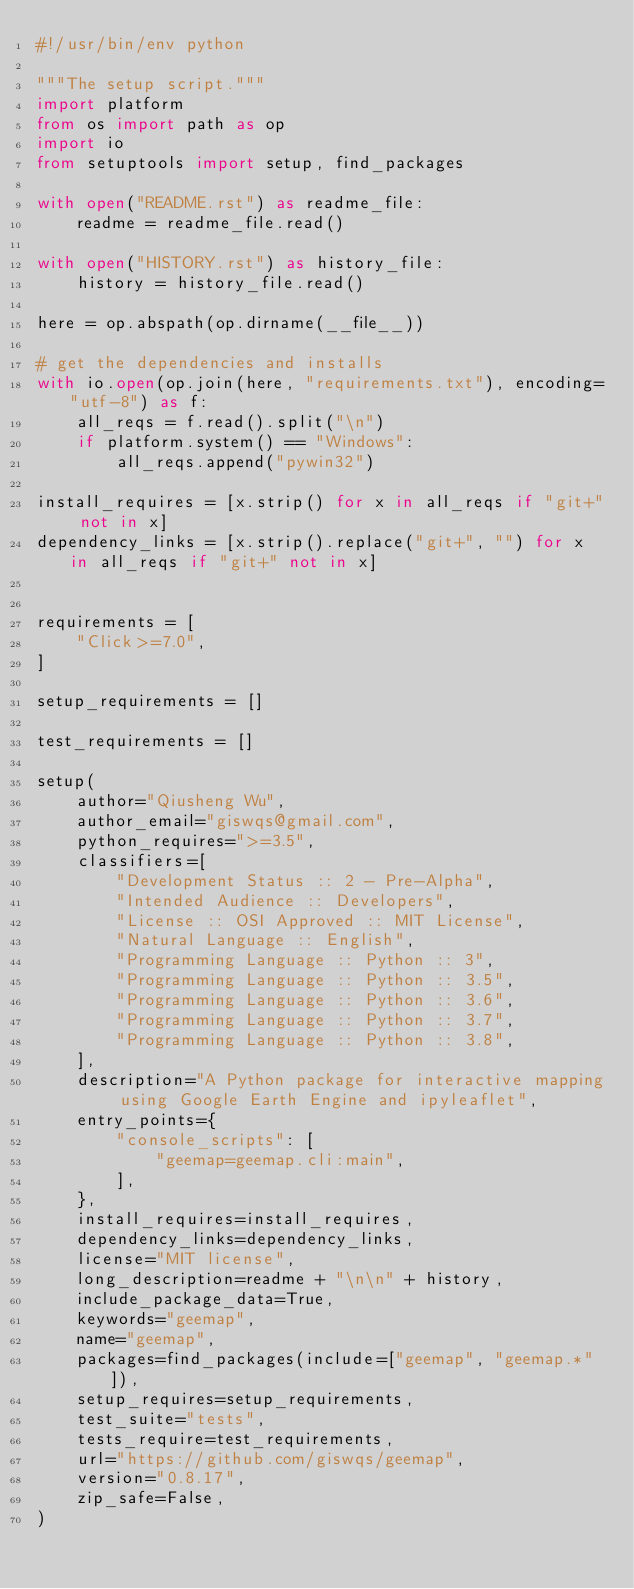<code> <loc_0><loc_0><loc_500><loc_500><_Python_>#!/usr/bin/env python

"""The setup script."""
import platform
from os import path as op
import io
from setuptools import setup, find_packages

with open("README.rst") as readme_file:
    readme = readme_file.read()

with open("HISTORY.rst") as history_file:
    history = history_file.read()

here = op.abspath(op.dirname(__file__))

# get the dependencies and installs
with io.open(op.join(here, "requirements.txt"), encoding="utf-8") as f:
    all_reqs = f.read().split("\n")
    if platform.system() == "Windows":
        all_reqs.append("pywin32")

install_requires = [x.strip() for x in all_reqs if "git+" not in x]
dependency_links = [x.strip().replace("git+", "") for x in all_reqs if "git+" not in x]


requirements = [
    "Click>=7.0",
]

setup_requirements = []

test_requirements = []

setup(
    author="Qiusheng Wu",
    author_email="giswqs@gmail.com",
    python_requires=">=3.5",
    classifiers=[
        "Development Status :: 2 - Pre-Alpha",
        "Intended Audience :: Developers",
        "License :: OSI Approved :: MIT License",
        "Natural Language :: English",
        "Programming Language :: Python :: 3",
        "Programming Language :: Python :: 3.5",
        "Programming Language :: Python :: 3.6",
        "Programming Language :: Python :: 3.7",
        "Programming Language :: Python :: 3.8",
    ],
    description="A Python package for interactive mapping using Google Earth Engine and ipyleaflet",
    entry_points={
        "console_scripts": [
            "geemap=geemap.cli:main",
        ],
    },
    install_requires=install_requires,
    dependency_links=dependency_links,
    license="MIT license",
    long_description=readme + "\n\n" + history,
    include_package_data=True,
    keywords="geemap",
    name="geemap",
    packages=find_packages(include=["geemap", "geemap.*"]),
    setup_requires=setup_requirements,
    test_suite="tests",
    tests_require=test_requirements,
    url="https://github.com/giswqs/geemap",
    version="0.8.17",
    zip_safe=False,
)
</code> 